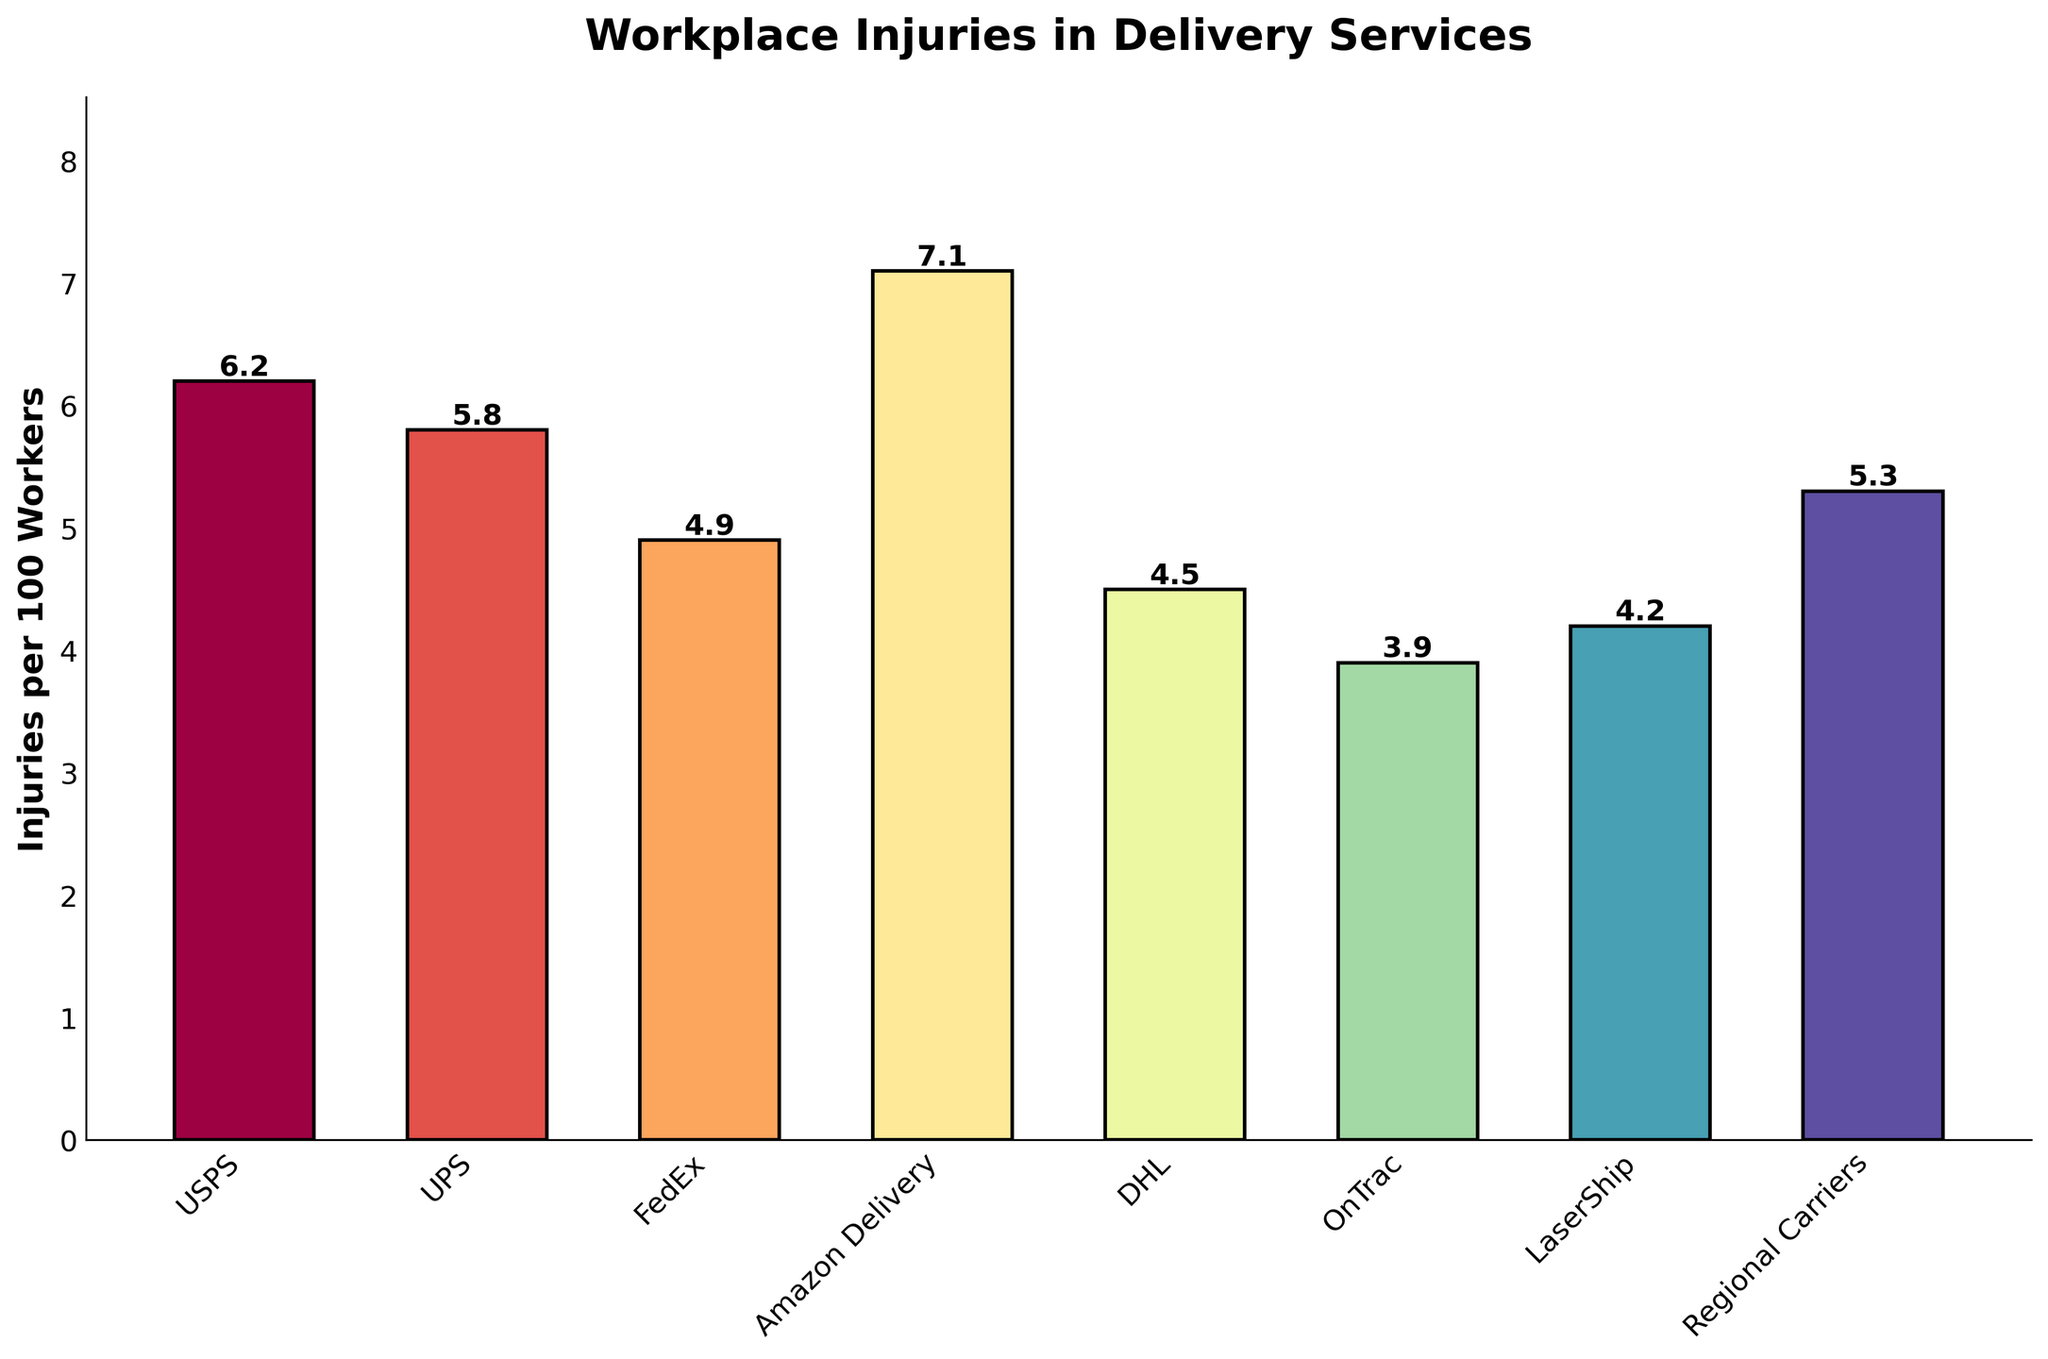Which service has the highest number of workplace injuries per 100 workers? Amazon Delivery has the highest bar, indicating the highest number of workplace injuries per 100 workers.
Answer: Amazon Delivery Which service has the lowest number of workplace injuries per 100 workers? OnTrac has the shortest bar, indicating the lowest number of workplace injuries per 100 workers.
Answer: OnTrac What is the difference in workplace injuries per 100 workers between USPS and UPS? USPS has 6.2 injuries per 100 workers, whereas UPS has 5.8. The difference is 6.2 - 5.8 = 0.4.
Answer: 0.4 Is the number of workplace injuries per 100 workers at FedEx more or less than DHL? FedEx has a taller bar than DHL, indicating more workplace injuries per 100 workers. FedEx has 4.9, and DHL has 4.5 injuries per 100 workers.
Answer: More Which service has almost twice the workplace injuries per 100 workers compared to OnTrac? OnTrac has 3.9 injuries, and Amazon Delivery has 7.1. Amazon Delivery's injuries are nearly twice as much as OnTrac's.
Answer: Amazon Delivery What is the combined number of workplace injuries per 100 workers for USPS, FedEx, and DHL? Adding the values from the bars for USPS (6.2), FedEx (4.9), and DHL (4.5): 6.2 + 4.9 + 4.5 = 15.6.
Answer: 15.6 Among the listed services, which two have the closest number of workplace injuries per 100 workers? USPS (6.2) and UPS (5.8) have the closest numbers, with a difference of just 0.4.
Answer: USPS and UPS How much higher are the workplace injuries per 100 workers in Amazon Delivery compared to LaserShip? Amazon Delivery has 7.1 injuries, and LaserShip has 4.2. The difference is 7.1 - 4.2 = 2.9.
Answer: 2.9 Are the workplace injuries per 100 workers at USPS above or below the median value of all the listed services? Arranging the values: 3.9, 4.2, 4.5, 4.9, 5.3, 5.8, 6.2, 7.1. The median is the average of 4.9 and 5.3, which is (4.9 + 5.3) / 2 = 5.1. USPS (6.2) is above the median.
Answer: Above 